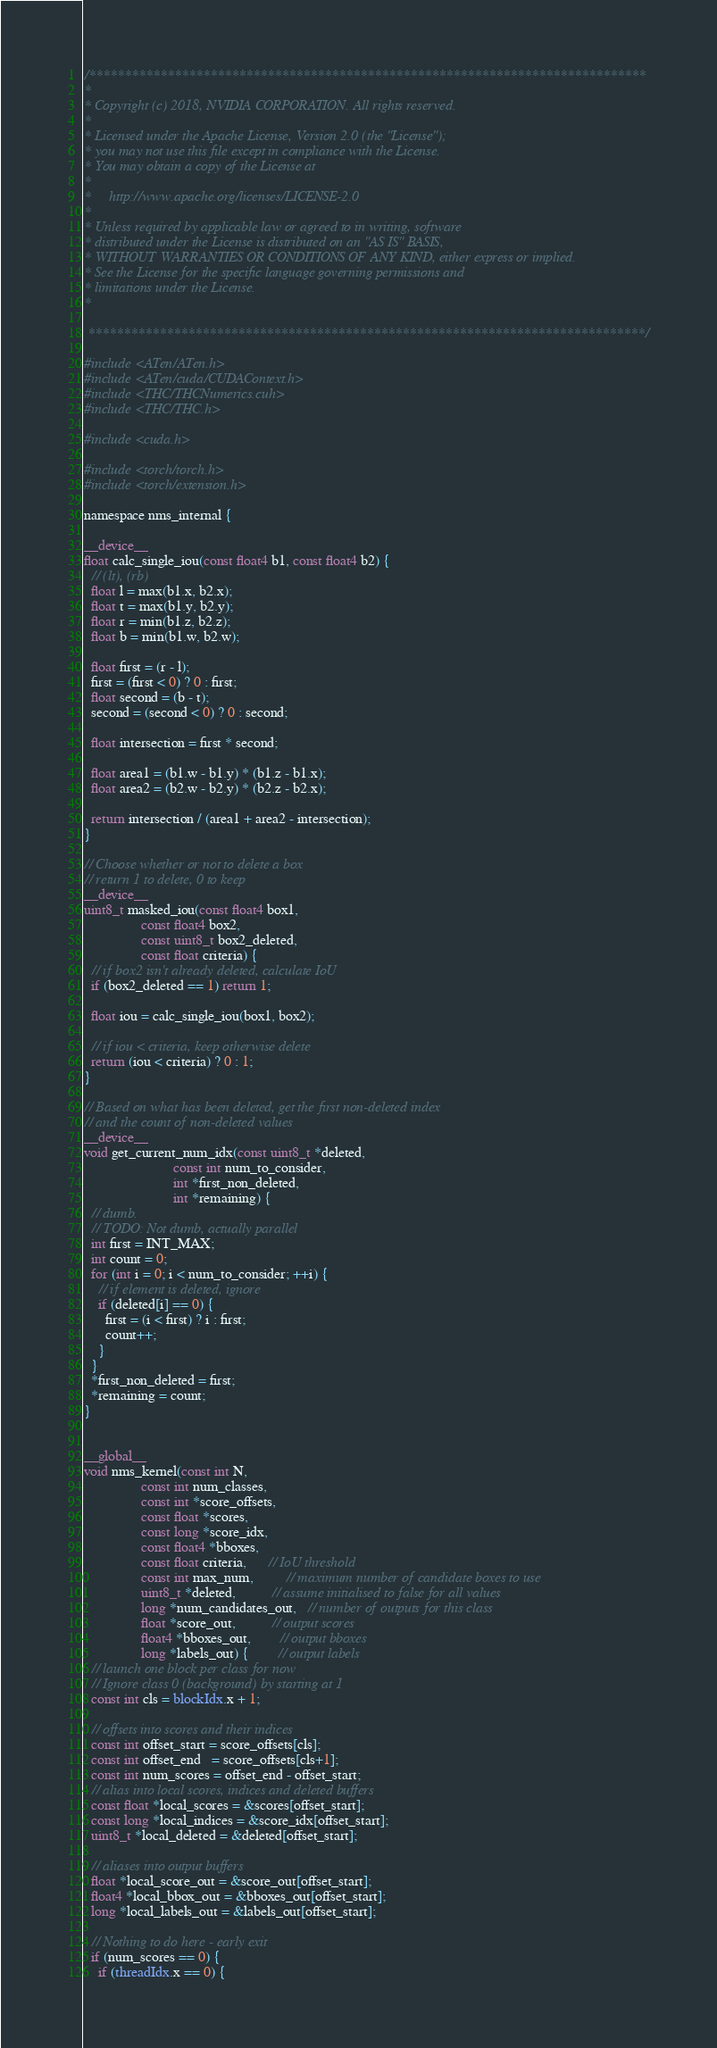<code> <loc_0><loc_0><loc_500><loc_500><_Cuda_>/******************************************************************************
*
* Copyright (c) 2018, NVIDIA CORPORATION. All rights reserved.
*
* Licensed under the Apache License, Version 2.0 (the "License");
* you may not use this file except in compliance with the License.
* You may obtain a copy of the License at
*
*     http://www.apache.org/licenses/LICENSE-2.0
*
* Unless required by applicable law or agreed to in writing, software
* distributed under the License is distributed on an "AS IS" BASIS,
* WITHOUT WARRANTIES OR CONDITIONS OF ANY KIND, either express or implied.
* See the License for the specific language governing permissions and
* limitations under the License.
*

 ******************************************************************************/

#include <ATen/ATen.h>
#include <ATen/cuda/CUDAContext.h>
#include <THC/THCNumerics.cuh>
#include <THC/THC.h>

#include <cuda.h>

#include <torch/torch.h>
#include <torch/extension.h>

namespace nms_internal {

__device__
float calc_single_iou(const float4 b1, const float4 b2) {
  // (lt), (rb)
  float l = max(b1.x, b2.x);
  float t = max(b1.y, b2.y);
  float r = min(b1.z, b2.z);
  float b = min(b1.w, b2.w);

  float first = (r - l);
  first = (first < 0) ? 0 : first;
  float second = (b - t);
  second = (second < 0) ? 0 : second;

  float intersection = first * second;

  float area1 = (b1.w - b1.y) * (b1.z - b1.x);
  float area2 = (b2.w - b2.y) * (b2.z - b2.x);

  return intersection / (area1 + area2 - intersection);
}

// Choose whether or not to delete a box
// return 1 to delete, 0 to keep
__device__
uint8_t masked_iou(const float4 box1,
                const float4 box2,
                const uint8_t box2_deleted,
                const float criteria) {
  // if box2 isn't already deleted, calculate IoU
  if (box2_deleted == 1) return 1;

  float iou = calc_single_iou(box1, box2);

  // if iou < criteria, keep otherwise delete
  return (iou < criteria) ? 0 : 1;
}

// Based on what has been deleted, get the first non-deleted index
// and the count of non-deleted values
__device__
void get_current_num_idx(const uint8_t *deleted,
                         const int num_to_consider,
                         int *first_non_deleted,
                         int *remaining) {
  // dumb.
  // TODO: Not dumb, actually parallel
  int first = INT_MAX;
  int count = 0;
  for (int i = 0; i < num_to_consider; ++i) {
    // if element is deleted, ignore
    if (deleted[i] == 0) {
      first = (i < first) ? i : first;
      count++;
    }
  }
  *first_non_deleted = first;
  *remaining = count;
}


__global__
void nms_kernel(const int N,
                const int num_classes,
                const int *score_offsets,
                const float *scores,
                const long *score_idx,
                const float4 *bboxes,
                const float criteria,      // IoU threshold
                const int max_num,         // maximum number of candidate boxes to use
                uint8_t *deleted,          // assume initialised to false for all values
                long *num_candidates_out,   // number of outputs for this class
                float *score_out,          // output scores
                float4 *bboxes_out,        // output bboxes
                long *labels_out) {        // output labels
  // launch one block per class for now
  // Ignore class 0 (background) by starting at 1
  const int cls = blockIdx.x + 1;

  // offsets into scores and their indices
  const int offset_start = score_offsets[cls];
  const int offset_end   = score_offsets[cls+1];
  const int num_scores = offset_end - offset_start;
  // alias into local scores, indices and deleted buffers
  const float *local_scores = &scores[offset_start];
  const long *local_indices = &score_idx[offset_start];
  uint8_t *local_deleted = &deleted[offset_start];

  // aliases into output buffers
  float *local_score_out = &score_out[offset_start];
  float4 *local_bbox_out = &bboxes_out[offset_start];
  long *local_labels_out = &labels_out[offset_start];

  // Nothing to do here - early exit
  if (num_scores == 0) {
    if (threadIdx.x == 0) {</code> 